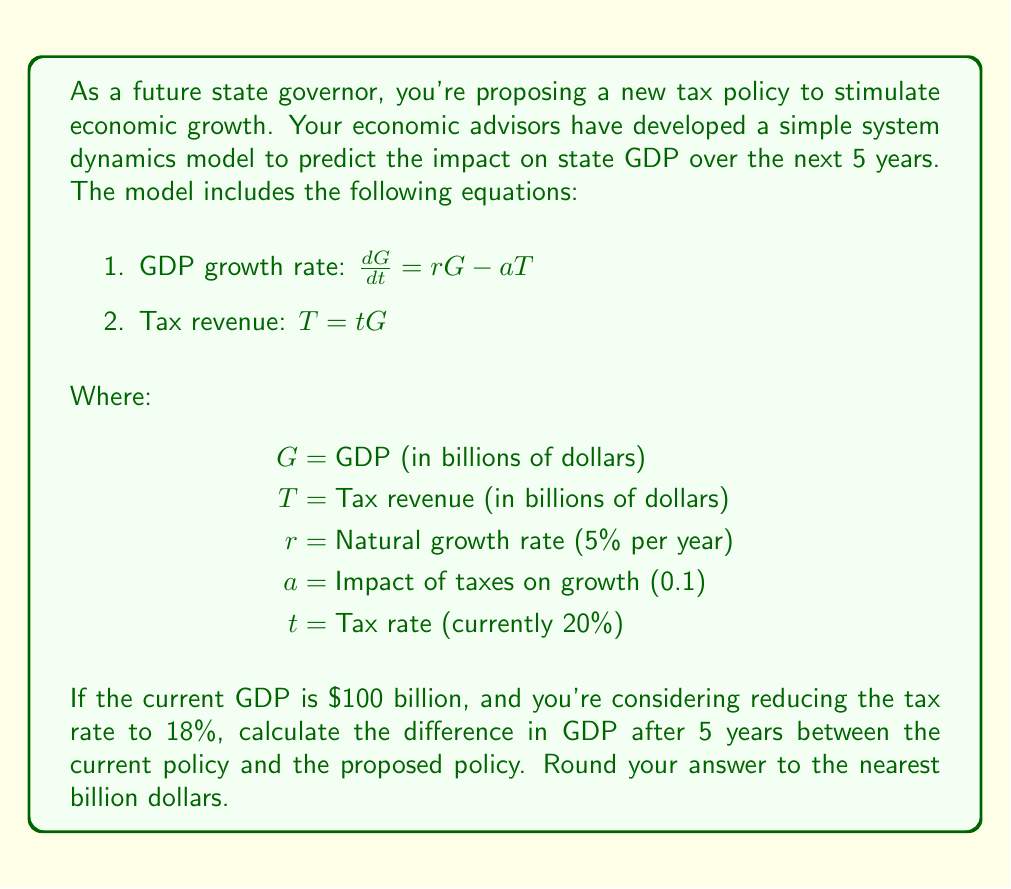Show me your answer to this math problem. To solve this problem, we need to use the system dynamics model to simulate the GDP growth under both tax rates over 5 years. We'll use the Euler method for numerical integration with a time step of 1 year.

Step 1: Set up the initial conditions and parameters
- Initial GDP ($G_0$) = $100 billion
- Natural growth rate ($r$) = 5% = 0.05
- Impact of taxes on growth ($a$) = 0.1
- Time step ($\Delta t$) = 1 year
- Total time ($T$) = 5 years

Step 2: Calculate GDP growth for current policy (t = 20% = 0.20)
For each year i from 1 to 5:
$$G_i = G_{i-1} + \Delta t \cdot (rG_{i-1} - aT_{i-1})$$
$$T_{i-1} = tG_{i-1}$$

Year 1: $G_1 = 100 + 1 \cdot (0.05 \cdot 100 - 0.1 \cdot 20) = 103$
Year 2: $G_2 = 103 + 1 \cdot (0.05 \cdot 103 - 0.1 \cdot 20.6) = 106.09$
Year 3: $G_3 = 106.09 + 1 \cdot (0.05 \cdot 106.09 - 0.1 \cdot 21.218) = 109.27$
Year 4: $G_4 = 109.27 + 1 \cdot (0.05 \cdot 109.27 - 0.1 \cdot 21.854) = 112.55$
Year 5: $G_5 = 112.55 + 1 \cdot (0.05 \cdot 112.55 - 0.1 \cdot 22.51) = 115.93$

Step 3: Calculate GDP growth for proposed policy (t = 18% = 0.18)
Using the same method:

Year 1: $G_1 = 100 + 1 \cdot (0.05 \cdot 100 - 0.1 \cdot 18) = 103.2$
Year 2: $G_2 = 103.2 + 1 \cdot (0.05 \cdot 103.2 - 0.1 \cdot 18.576) = 106.5$
Year 3: $G_3 = 106.5 + 1 \cdot (0.05 \cdot 106.5 - 0.1 \cdot 19.17) = 109.91$
Year 4: $G_4 = 109.91 + 1 \cdot (0.05 \cdot 109.91 - 0.1 \cdot 19.7838) = 113.43$
Year 5: $G_5 = 113.43 + 1 \cdot (0.05 \cdot 113.43 - 0.1 \cdot 20.4174) = 117.06$

Step 4: Calculate the difference in GDP after 5 years
Difference = Proposed policy GDP - Current policy GDP
= 117.06 - 115.93 = 1.13 billion dollars

Rounding to the nearest billion: 1 billion dollars
Answer: $1 billion 